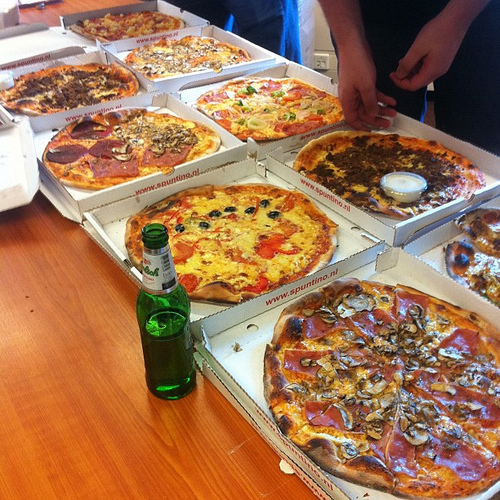Are there any onions to the left of the sausage on the right side? No, there are no onions to the left of the sausage on the right side. 